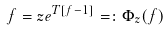Convert formula to latex. <formula><loc_0><loc_0><loc_500><loc_500>f = z e ^ { T [ f - 1 ] } = \colon \Phi _ { z } ( f )</formula> 